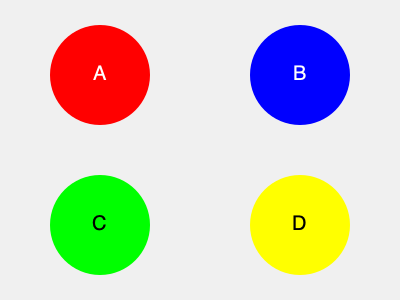Match the colored circles to their corresponding subcompact car manufacturers: 1. Fiat, 2. Smart, 3. Mini, 4. Chevrolet (Spark). Which letter represents the logo color of Mini? To solve this puzzle, let's analyze each manufacturer's logo color:

1. Fiat: The primary color in Fiat's logo is red.
2. Smart: The logo for Smart cars is typically blue and white.
3. Mini: Mini's logo features black text on a white background, often with a winged emblem.
4. Chevrolet (Spark): Chevrolet's logo, which applies to the Spark model, is gold (yellow) on a blue background.

Now, let's match these to the colored circles in the image:

A (Red): This matches Fiat's logo color.
B (Blue): This corresponds to Smart's logo color.
C (Green): This doesn't directly match any of the given manufacturers.
D (Yellow): This aligns with Chevrolet's gold logo color.

The question asks specifically about Mini. Mini's logo is primarily black and white, which is not represented by any of the colored circles. However, the black text of Mini's logo is closest to the dark color used for the letter "C" in the green circle.

Therefore, the letter that best represents Mini's logo color is C.
Answer: C 